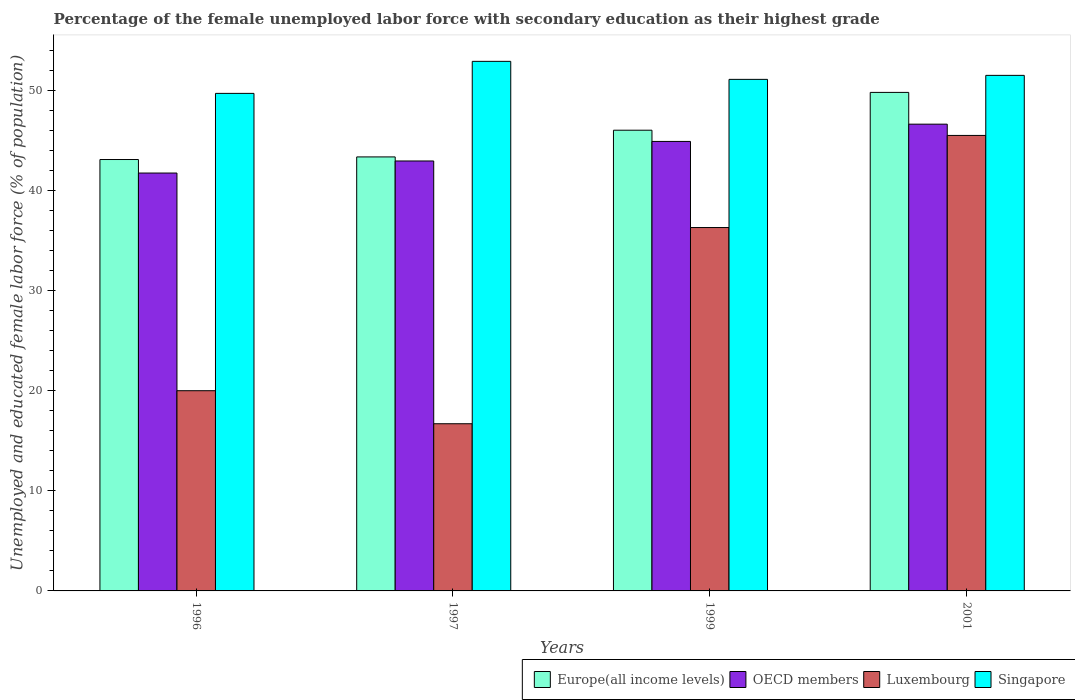Are the number of bars per tick equal to the number of legend labels?
Offer a terse response. Yes. Are the number of bars on each tick of the X-axis equal?
Your answer should be compact. Yes. How many bars are there on the 3rd tick from the left?
Provide a short and direct response. 4. In how many cases, is the number of bars for a given year not equal to the number of legend labels?
Make the answer very short. 0. What is the percentage of the unemployed female labor force with secondary education in Singapore in 1997?
Provide a succinct answer. 52.9. Across all years, what is the maximum percentage of the unemployed female labor force with secondary education in Singapore?
Offer a very short reply. 52.9. Across all years, what is the minimum percentage of the unemployed female labor force with secondary education in Europe(all income levels)?
Ensure brevity in your answer.  43.09. In which year was the percentage of the unemployed female labor force with secondary education in Luxembourg minimum?
Your response must be concise. 1997. What is the total percentage of the unemployed female labor force with secondary education in OECD members in the graph?
Provide a succinct answer. 176.22. What is the difference between the percentage of the unemployed female labor force with secondary education in Singapore in 1997 and that in 1999?
Provide a short and direct response. 1.8. What is the difference between the percentage of the unemployed female labor force with secondary education in OECD members in 2001 and the percentage of the unemployed female labor force with secondary education in Luxembourg in 1999?
Offer a very short reply. 10.33. What is the average percentage of the unemployed female labor force with secondary education in Europe(all income levels) per year?
Ensure brevity in your answer.  45.57. What is the ratio of the percentage of the unemployed female labor force with secondary education in OECD members in 1997 to that in 2001?
Your answer should be compact. 0.92. Is the percentage of the unemployed female labor force with secondary education in OECD members in 1997 less than that in 1999?
Provide a succinct answer. Yes. What is the difference between the highest and the second highest percentage of the unemployed female labor force with secondary education in Singapore?
Give a very brief answer. 1.4. What is the difference between the highest and the lowest percentage of the unemployed female labor force with secondary education in Europe(all income levels)?
Offer a very short reply. 6.7. In how many years, is the percentage of the unemployed female labor force with secondary education in Europe(all income levels) greater than the average percentage of the unemployed female labor force with secondary education in Europe(all income levels) taken over all years?
Give a very brief answer. 2. Is the sum of the percentage of the unemployed female labor force with secondary education in OECD members in 1996 and 1999 greater than the maximum percentage of the unemployed female labor force with secondary education in Singapore across all years?
Offer a terse response. Yes. Is it the case that in every year, the sum of the percentage of the unemployed female labor force with secondary education in Europe(all income levels) and percentage of the unemployed female labor force with secondary education in Singapore is greater than the sum of percentage of the unemployed female labor force with secondary education in OECD members and percentage of the unemployed female labor force with secondary education in Luxembourg?
Your answer should be compact. No. What does the 2nd bar from the left in 1999 represents?
Offer a terse response. OECD members. What does the 4th bar from the right in 1999 represents?
Provide a short and direct response. Europe(all income levels). Are all the bars in the graph horizontal?
Your answer should be very brief. No. How many years are there in the graph?
Give a very brief answer. 4. Are the values on the major ticks of Y-axis written in scientific E-notation?
Offer a terse response. No. Does the graph contain any zero values?
Provide a short and direct response. No. Does the graph contain grids?
Ensure brevity in your answer.  No. How are the legend labels stacked?
Your answer should be very brief. Horizontal. What is the title of the graph?
Provide a short and direct response. Percentage of the female unemployed labor force with secondary education as their highest grade. What is the label or title of the Y-axis?
Provide a succinct answer. Unemployed and educated female labor force (% of population). What is the Unemployed and educated female labor force (% of population) in Europe(all income levels) in 1996?
Provide a short and direct response. 43.09. What is the Unemployed and educated female labor force (% of population) in OECD members in 1996?
Your response must be concise. 41.74. What is the Unemployed and educated female labor force (% of population) of Luxembourg in 1996?
Make the answer very short. 20. What is the Unemployed and educated female labor force (% of population) of Singapore in 1996?
Provide a short and direct response. 49.7. What is the Unemployed and educated female labor force (% of population) in Europe(all income levels) in 1997?
Offer a terse response. 43.35. What is the Unemployed and educated female labor force (% of population) of OECD members in 1997?
Your response must be concise. 42.95. What is the Unemployed and educated female labor force (% of population) of Luxembourg in 1997?
Your response must be concise. 16.7. What is the Unemployed and educated female labor force (% of population) in Singapore in 1997?
Give a very brief answer. 52.9. What is the Unemployed and educated female labor force (% of population) of Europe(all income levels) in 1999?
Offer a very short reply. 46.02. What is the Unemployed and educated female labor force (% of population) of OECD members in 1999?
Offer a terse response. 44.9. What is the Unemployed and educated female labor force (% of population) of Luxembourg in 1999?
Your answer should be compact. 36.3. What is the Unemployed and educated female labor force (% of population) in Singapore in 1999?
Give a very brief answer. 51.1. What is the Unemployed and educated female labor force (% of population) of Europe(all income levels) in 2001?
Keep it short and to the point. 49.8. What is the Unemployed and educated female labor force (% of population) of OECD members in 2001?
Offer a terse response. 46.63. What is the Unemployed and educated female labor force (% of population) of Luxembourg in 2001?
Give a very brief answer. 45.5. What is the Unemployed and educated female labor force (% of population) in Singapore in 2001?
Offer a terse response. 51.5. Across all years, what is the maximum Unemployed and educated female labor force (% of population) of Europe(all income levels)?
Ensure brevity in your answer.  49.8. Across all years, what is the maximum Unemployed and educated female labor force (% of population) of OECD members?
Offer a terse response. 46.63. Across all years, what is the maximum Unemployed and educated female labor force (% of population) in Luxembourg?
Your response must be concise. 45.5. Across all years, what is the maximum Unemployed and educated female labor force (% of population) of Singapore?
Provide a succinct answer. 52.9. Across all years, what is the minimum Unemployed and educated female labor force (% of population) of Europe(all income levels)?
Give a very brief answer. 43.09. Across all years, what is the minimum Unemployed and educated female labor force (% of population) in OECD members?
Your answer should be compact. 41.74. Across all years, what is the minimum Unemployed and educated female labor force (% of population) in Luxembourg?
Make the answer very short. 16.7. Across all years, what is the minimum Unemployed and educated female labor force (% of population) of Singapore?
Make the answer very short. 49.7. What is the total Unemployed and educated female labor force (% of population) in Europe(all income levels) in the graph?
Keep it short and to the point. 182.27. What is the total Unemployed and educated female labor force (% of population) of OECD members in the graph?
Your answer should be very brief. 176.22. What is the total Unemployed and educated female labor force (% of population) in Luxembourg in the graph?
Give a very brief answer. 118.5. What is the total Unemployed and educated female labor force (% of population) of Singapore in the graph?
Your answer should be compact. 205.2. What is the difference between the Unemployed and educated female labor force (% of population) in Europe(all income levels) in 1996 and that in 1997?
Offer a terse response. -0.26. What is the difference between the Unemployed and educated female labor force (% of population) of OECD members in 1996 and that in 1997?
Offer a terse response. -1.2. What is the difference between the Unemployed and educated female labor force (% of population) of Luxembourg in 1996 and that in 1997?
Your answer should be very brief. 3.3. What is the difference between the Unemployed and educated female labor force (% of population) in Europe(all income levels) in 1996 and that in 1999?
Ensure brevity in your answer.  -2.93. What is the difference between the Unemployed and educated female labor force (% of population) of OECD members in 1996 and that in 1999?
Your answer should be very brief. -3.16. What is the difference between the Unemployed and educated female labor force (% of population) of Luxembourg in 1996 and that in 1999?
Provide a short and direct response. -16.3. What is the difference between the Unemployed and educated female labor force (% of population) in Europe(all income levels) in 1996 and that in 2001?
Offer a terse response. -6.7. What is the difference between the Unemployed and educated female labor force (% of population) in OECD members in 1996 and that in 2001?
Your answer should be very brief. -4.88. What is the difference between the Unemployed and educated female labor force (% of population) in Luxembourg in 1996 and that in 2001?
Your answer should be very brief. -25.5. What is the difference between the Unemployed and educated female labor force (% of population) of Singapore in 1996 and that in 2001?
Ensure brevity in your answer.  -1.8. What is the difference between the Unemployed and educated female labor force (% of population) in Europe(all income levels) in 1997 and that in 1999?
Your answer should be compact. -2.67. What is the difference between the Unemployed and educated female labor force (% of population) of OECD members in 1997 and that in 1999?
Offer a terse response. -1.95. What is the difference between the Unemployed and educated female labor force (% of population) of Luxembourg in 1997 and that in 1999?
Make the answer very short. -19.6. What is the difference between the Unemployed and educated female labor force (% of population) of Singapore in 1997 and that in 1999?
Offer a very short reply. 1.8. What is the difference between the Unemployed and educated female labor force (% of population) of Europe(all income levels) in 1997 and that in 2001?
Your response must be concise. -6.44. What is the difference between the Unemployed and educated female labor force (% of population) in OECD members in 1997 and that in 2001?
Provide a short and direct response. -3.68. What is the difference between the Unemployed and educated female labor force (% of population) of Luxembourg in 1997 and that in 2001?
Give a very brief answer. -28.8. What is the difference between the Unemployed and educated female labor force (% of population) in Europe(all income levels) in 1999 and that in 2001?
Your answer should be compact. -3.78. What is the difference between the Unemployed and educated female labor force (% of population) of OECD members in 1999 and that in 2001?
Ensure brevity in your answer.  -1.72. What is the difference between the Unemployed and educated female labor force (% of population) of Europe(all income levels) in 1996 and the Unemployed and educated female labor force (% of population) of OECD members in 1997?
Provide a succinct answer. 0.14. What is the difference between the Unemployed and educated female labor force (% of population) in Europe(all income levels) in 1996 and the Unemployed and educated female labor force (% of population) in Luxembourg in 1997?
Provide a succinct answer. 26.39. What is the difference between the Unemployed and educated female labor force (% of population) of Europe(all income levels) in 1996 and the Unemployed and educated female labor force (% of population) of Singapore in 1997?
Your answer should be compact. -9.81. What is the difference between the Unemployed and educated female labor force (% of population) in OECD members in 1996 and the Unemployed and educated female labor force (% of population) in Luxembourg in 1997?
Your answer should be very brief. 25.04. What is the difference between the Unemployed and educated female labor force (% of population) in OECD members in 1996 and the Unemployed and educated female labor force (% of population) in Singapore in 1997?
Provide a succinct answer. -11.16. What is the difference between the Unemployed and educated female labor force (% of population) in Luxembourg in 1996 and the Unemployed and educated female labor force (% of population) in Singapore in 1997?
Your answer should be very brief. -32.9. What is the difference between the Unemployed and educated female labor force (% of population) of Europe(all income levels) in 1996 and the Unemployed and educated female labor force (% of population) of OECD members in 1999?
Offer a terse response. -1.81. What is the difference between the Unemployed and educated female labor force (% of population) of Europe(all income levels) in 1996 and the Unemployed and educated female labor force (% of population) of Luxembourg in 1999?
Provide a succinct answer. 6.79. What is the difference between the Unemployed and educated female labor force (% of population) in Europe(all income levels) in 1996 and the Unemployed and educated female labor force (% of population) in Singapore in 1999?
Offer a very short reply. -8.01. What is the difference between the Unemployed and educated female labor force (% of population) in OECD members in 1996 and the Unemployed and educated female labor force (% of population) in Luxembourg in 1999?
Offer a very short reply. 5.44. What is the difference between the Unemployed and educated female labor force (% of population) in OECD members in 1996 and the Unemployed and educated female labor force (% of population) in Singapore in 1999?
Provide a succinct answer. -9.36. What is the difference between the Unemployed and educated female labor force (% of population) of Luxembourg in 1996 and the Unemployed and educated female labor force (% of population) of Singapore in 1999?
Keep it short and to the point. -31.1. What is the difference between the Unemployed and educated female labor force (% of population) in Europe(all income levels) in 1996 and the Unemployed and educated female labor force (% of population) in OECD members in 2001?
Provide a succinct answer. -3.53. What is the difference between the Unemployed and educated female labor force (% of population) of Europe(all income levels) in 1996 and the Unemployed and educated female labor force (% of population) of Luxembourg in 2001?
Offer a very short reply. -2.41. What is the difference between the Unemployed and educated female labor force (% of population) in Europe(all income levels) in 1996 and the Unemployed and educated female labor force (% of population) in Singapore in 2001?
Provide a short and direct response. -8.41. What is the difference between the Unemployed and educated female labor force (% of population) of OECD members in 1996 and the Unemployed and educated female labor force (% of population) of Luxembourg in 2001?
Provide a short and direct response. -3.76. What is the difference between the Unemployed and educated female labor force (% of population) in OECD members in 1996 and the Unemployed and educated female labor force (% of population) in Singapore in 2001?
Offer a terse response. -9.76. What is the difference between the Unemployed and educated female labor force (% of population) of Luxembourg in 1996 and the Unemployed and educated female labor force (% of population) of Singapore in 2001?
Give a very brief answer. -31.5. What is the difference between the Unemployed and educated female labor force (% of population) in Europe(all income levels) in 1997 and the Unemployed and educated female labor force (% of population) in OECD members in 1999?
Your response must be concise. -1.55. What is the difference between the Unemployed and educated female labor force (% of population) in Europe(all income levels) in 1997 and the Unemployed and educated female labor force (% of population) in Luxembourg in 1999?
Keep it short and to the point. 7.05. What is the difference between the Unemployed and educated female labor force (% of population) of Europe(all income levels) in 1997 and the Unemployed and educated female labor force (% of population) of Singapore in 1999?
Offer a terse response. -7.75. What is the difference between the Unemployed and educated female labor force (% of population) in OECD members in 1997 and the Unemployed and educated female labor force (% of population) in Luxembourg in 1999?
Offer a terse response. 6.65. What is the difference between the Unemployed and educated female labor force (% of population) of OECD members in 1997 and the Unemployed and educated female labor force (% of population) of Singapore in 1999?
Provide a succinct answer. -8.15. What is the difference between the Unemployed and educated female labor force (% of population) in Luxembourg in 1997 and the Unemployed and educated female labor force (% of population) in Singapore in 1999?
Your answer should be very brief. -34.4. What is the difference between the Unemployed and educated female labor force (% of population) of Europe(all income levels) in 1997 and the Unemployed and educated female labor force (% of population) of OECD members in 2001?
Give a very brief answer. -3.27. What is the difference between the Unemployed and educated female labor force (% of population) in Europe(all income levels) in 1997 and the Unemployed and educated female labor force (% of population) in Luxembourg in 2001?
Provide a short and direct response. -2.15. What is the difference between the Unemployed and educated female labor force (% of population) of Europe(all income levels) in 1997 and the Unemployed and educated female labor force (% of population) of Singapore in 2001?
Provide a short and direct response. -8.15. What is the difference between the Unemployed and educated female labor force (% of population) of OECD members in 1997 and the Unemployed and educated female labor force (% of population) of Luxembourg in 2001?
Make the answer very short. -2.55. What is the difference between the Unemployed and educated female labor force (% of population) of OECD members in 1997 and the Unemployed and educated female labor force (% of population) of Singapore in 2001?
Provide a succinct answer. -8.55. What is the difference between the Unemployed and educated female labor force (% of population) of Luxembourg in 1997 and the Unemployed and educated female labor force (% of population) of Singapore in 2001?
Offer a terse response. -34.8. What is the difference between the Unemployed and educated female labor force (% of population) in Europe(all income levels) in 1999 and the Unemployed and educated female labor force (% of population) in OECD members in 2001?
Your response must be concise. -0.6. What is the difference between the Unemployed and educated female labor force (% of population) of Europe(all income levels) in 1999 and the Unemployed and educated female labor force (% of population) of Luxembourg in 2001?
Offer a terse response. 0.52. What is the difference between the Unemployed and educated female labor force (% of population) of Europe(all income levels) in 1999 and the Unemployed and educated female labor force (% of population) of Singapore in 2001?
Make the answer very short. -5.48. What is the difference between the Unemployed and educated female labor force (% of population) of OECD members in 1999 and the Unemployed and educated female labor force (% of population) of Luxembourg in 2001?
Offer a very short reply. -0.6. What is the difference between the Unemployed and educated female labor force (% of population) in OECD members in 1999 and the Unemployed and educated female labor force (% of population) in Singapore in 2001?
Offer a terse response. -6.6. What is the difference between the Unemployed and educated female labor force (% of population) in Luxembourg in 1999 and the Unemployed and educated female labor force (% of population) in Singapore in 2001?
Provide a short and direct response. -15.2. What is the average Unemployed and educated female labor force (% of population) in Europe(all income levels) per year?
Keep it short and to the point. 45.57. What is the average Unemployed and educated female labor force (% of population) of OECD members per year?
Make the answer very short. 44.05. What is the average Unemployed and educated female labor force (% of population) of Luxembourg per year?
Your answer should be compact. 29.62. What is the average Unemployed and educated female labor force (% of population) of Singapore per year?
Provide a succinct answer. 51.3. In the year 1996, what is the difference between the Unemployed and educated female labor force (% of population) of Europe(all income levels) and Unemployed and educated female labor force (% of population) of OECD members?
Offer a very short reply. 1.35. In the year 1996, what is the difference between the Unemployed and educated female labor force (% of population) of Europe(all income levels) and Unemployed and educated female labor force (% of population) of Luxembourg?
Make the answer very short. 23.09. In the year 1996, what is the difference between the Unemployed and educated female labor force (% of population) of Europe(all income levels) and Unemployed and educated female labor force (% of population) of Singapore?
Your answer should be very brief. -6.61. In the year 1996, what is the difference between the Unemployed and educated female labor force (% of population) of OECD members and Unemployed and educated female labor force (% of population) of Luxembourg?
Keep it short and to the point. 21.74. In the year 1996, what is the difference between the Unemployed and educated female labor force (% of population) of OECD members and Unemployed and educated female labor force (% of population) of Singapore?
Your response must be concise. -7.96. In the year 1996, what is the difference between the Unemployed and educated female labor force (% of population) in Luxembourg and Unemployed and educated female labor force (% of population) in Singapore?
Give a very brief answer. -29.7. In the year 1997, what is the difference between the Unemployed and educated female labor force (% of population) in Europe(all income levels) and Unemployed and educated female labor force (% of population) in OECD members?
Your response must be concise. 0.41. In the year 1997, what is the difference between the Unemployed and educated female labor force (% of population) in Europe(all income levels) and Unemployed and educated female labor force (% of population) in Luxembourg?
Keep it short and to the point. 26.65. In the year 1997, what is the difference between the Unemployed and educated female labor force (% of population) of Europe(all income levels) and Unemployed and educated female labor force (% of population) of Singapore?
Your answer should be compact. -9.55. In the year 1997, what is the difference between the Unemployed and educated female labor force (% of population) of OECD members and Unemployed and educated female labor force (% of population) of Luxembourg?
Give a very brief answer. 26.25. In the year 1997, what is the difference between the Unemployed and educated female labor force (% of population) of OECD members and Unemployed and educated female labor force (% of population) of Singapore?
Provide a succinct answer. -9.95. In the year 1997, what is the difference between the Unemployed and educated female labor force (% of population) in Luxembourg and Unemployed and educated female labor force (% of population) in Singapore?
Provide a succinct answer. -36.2. In the year 1999, what is the difference between the Unemployed and educated female labor force (% of population) of Europe(all income levels) and Unemployed and educated female labor force (% of population) of OECD members?
Your answer should be compact. 1.12. In the year 1999, what is the difference between the Unemployed and educated female labor force (% of population) of Europe(all income levels) and Unemployed and educated female labor force (% of population) of Luxembourg?
Ensure brevity in your answer.  9.72. In the year 1999, what is the difference between the Unemployed and educated female labor force (% of population) in Europe(all income levels) and Unemployed and educated female labor force (% of population) in Singapore?
Ensure brevity in your answer.  -5.08. In the year 1999, what is the difference between the Unemployed and educated female labor force (% of population) of OECD members and Unemployed and educated female labor force (% of population) of Luxembourg?
Offer a very short reply. 8.6. In the year 1999, what is the difference between the Unemployed and educated female labor force (% of population) of OECD members and Unemployed and educated female labor force (% of population) of Singapore?
Provide a short and direct response. -6.2. In the year 1999, what is the difference between the Unemployed and educated female labor force (% of population) of Luxembourg and Unemployed and educated female labor force (% of population) of Singapore?
Offer a very short reply. -14.8. In the year 2001, what is the difference between the Unemployed and educated female labor force (% of population) of Europe(all income levels) and Unemployed and educated female labor force (% of population) of OECD members?
Offer a very short reply. 3.17. In the year 2001, what is the difference between the Unemployed and educated female labor force (% of population) in Europe(all income levels) and Unemployed and educated female labor force (% of population) in Luxembourg?
Ensure brevity in your answer.  4.3. In the year 2001, what is the difference between the Unemployed and educated female labor force (% of population) in Europe(all income levels) and Unemployed and educated female labor force (% of population) in Singapore?
Your response must be concise. -1.7. In the year 2001, what is the difference between the Unemployed and educated female labor force (% of population) of OECD members and Unemployed and educated female labor force (% of population) of Luxembourg?
Give a very brief answer. 1.13. In the year 2001, what is the difference between the Unemployed and educated female labor force (% of population) in OECD members and Unemployed and educated female labor force (% of population) in Singapore?
Offer a very short reply. -4.87. What is the ratio of the Unemployed and educated female labor force (% of population) in Europe(all income levels) in 1996 to that in 1997?
Ensure brevity in your answer.  0.99. What is the ratio of the Unemployed and educated female labor force (% of population) in OECD members in 1996 to that in 1997?
Ensure brevity in your answer.  0.97. What is the ratio of the Unemployed and educated female labor force (% of population) of Luxembourg in 1996 to that in 1997?
Give a very brief answer. 1.2. What is the ratio of the Unemployed and educated female labor force (% of population) of Singapore in 1996 to that in 1997?
Your response must be concise. 0.94. What is the ratio of the Unemployed and educated female labor force (% of population) of Europe(all income levels) in 1996 to that in 1999?
Make the answer very short. 0.94. What is the ratio of the Unemployed and educated female labor force (% of population) in OECD members in 1996 to that in 1999?
Your response must be concise. 0.93. What is the ratio of the Unemployed and educated female labor force (% of population) in Luxembourg in 1996 to that in 1999?
Provide a succinct answer. 0.55. What is the ratio of the Unemployed and educated female labor force (% of population) in Singapore in 1996 to that in 1999?
Offer a very short reply. 0.97. What is the ratio of the Unemployed and educated female labor force (% of population) in Europe(all income levels) in 1996 to that in 2001?
Make the answer very short. 0.87. What is the ratio of the Unemployed and educated female labor force (% of population) of OECD members in 1996 to that in 2001?
Your response must be concise. 0.9. What is the ratio of the Unemployed and educated female labor force (% of population) of Luxembourg in 1996 to that in 2001?
Ensure brevity in your answer.  0.44. What is the ratio of the Unemployed and educated female labor force (% of population) in Europe(all income levels) in 1997 to that in 1999?
Offer a terse response. 0.94. What is the ratio of the Unemployed and educated female labor force (% of population) of OECD members in 1997 to that in 1999?
Provide a succinct answer. 0.96. What is the ratio of the Unemployed and educated female labor force (% of population) of Luxembourg in 1997 to that in 1999?
Your answer should be very brief. 0.46. What is the ratio of the Unemployed and educated female labor force (% of population) in Singapore in 1997 to that in 1999?
Offer a terse response. 1.04. What is the ratio of the Unemployed and educated female labor force (% of population) in Europe(all income levels) in 1997 to that in 2001?
Keep it short and to the point. 0.87. What is the ratio of the Unemployed and educated female labor force (% of population) of OECD members in 1997 to that in 2001?
Make the answer very short. 0.92. What is the ratio of the Unemployed and educated female labor force (% of population) of Luxembourg in 1997 to that in 2001?
Give a very brief answer. 0.37. What is the ratio of the Unemployed and educated female labor force (% of population) in Singapore in 1997 to that in 2001?
Make the answer very short. 1.03. What is the ratio of the Unemployed and educated female labor force (% of population) of Europe(all income levels) in 1999 to that in 2001?
Provide a succinct answer. 0.92. What is the ratio of the Unemployed and educated female labor force (% of population) of OECD members in 1999 to that in 2001?
Offer a terse response. 0.96. What is the ratio of the Unemployed and educated female labor force (% of population) in Luxembourg in 1999 to that in 2001?
Your answer should be compact. 0.8. What is the difference between the highest and the second highest Unemployed and educated female labor force (% of population) of Europe(all income levels)?
Your answer should be very brief. 3.78. What is the difference between the highest and the second highest Unemployed and educated female labor force (% of population) of OECD members?
Offer a terse response. 1.72. What is the difference between the highest and the second highest Unemployed and educated female labor force (% of population) of Luxembourg?
Provide a short and direct response. 9.2. What is the difference between the highest and the lowest Unemployed and educated female labor force (% of population) in Europe(all income levels)?
Your answer should be very brief. 6.7. What is the difference between the highest and the lowest Unemployed and educated female labor force (% of population) of OECD members?
Keep it short and to the point. 4.88. What is the difference between the highest and the lowest Unemployed and educated female labor force (% of population) in Luxembourg?
Keep it short and to the point. 28.8. What is the difference between the highest and the lowest Unemployed and educated female labor force (% of population) in Singapore?
Offer a very short reply. 3.2. 